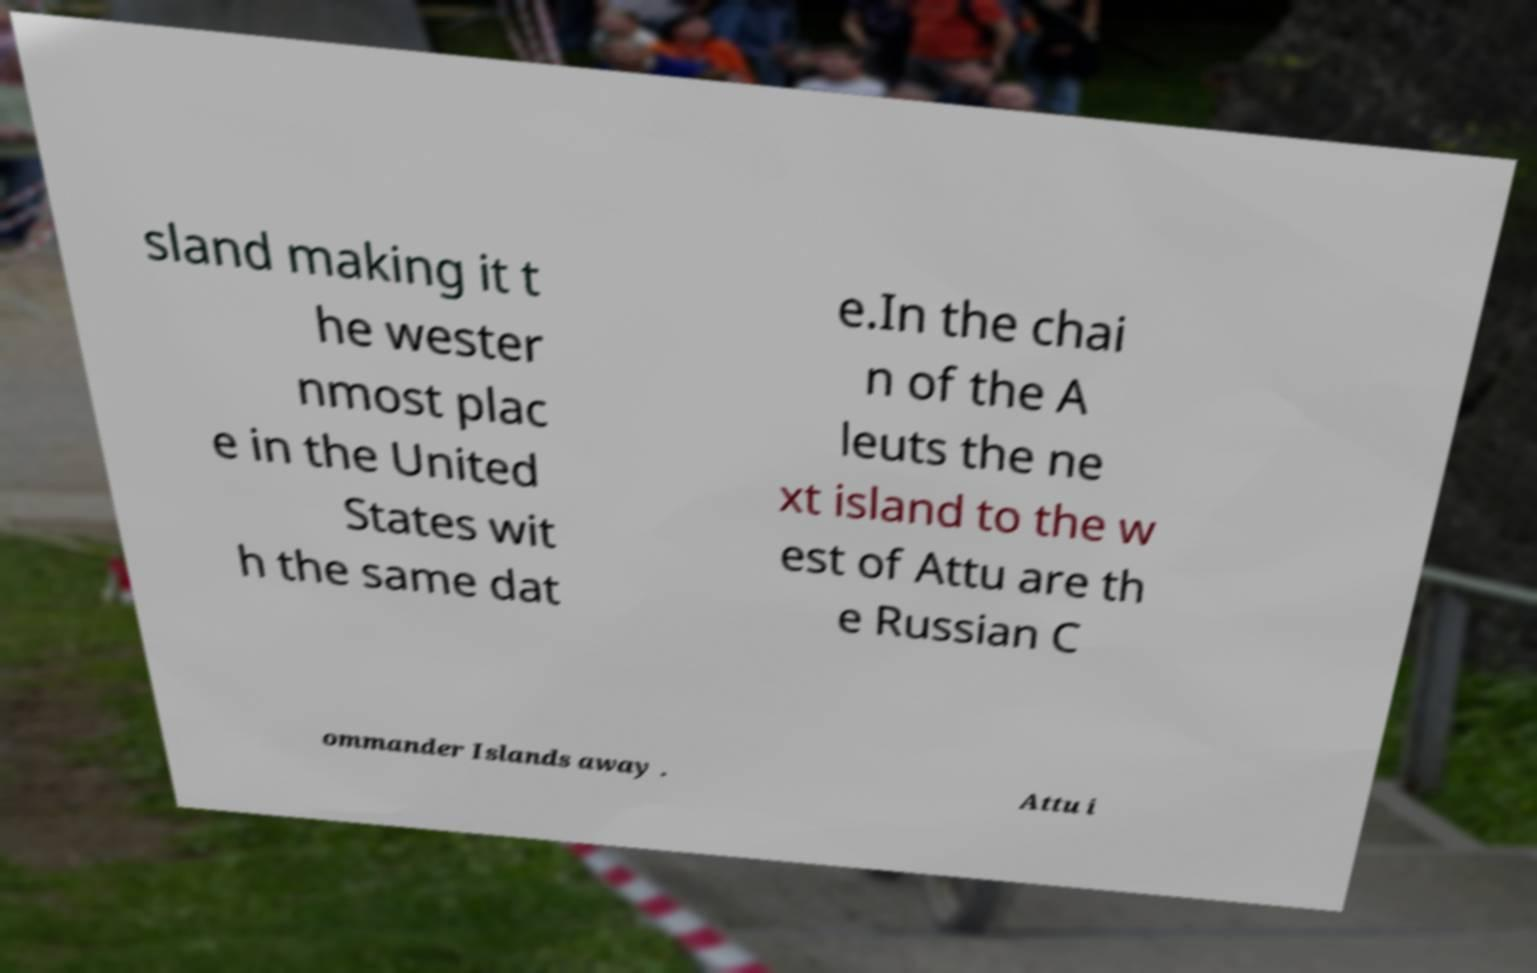For documentation purposes, I need the text within this image transcribed. Could you provide that? sland making it t he wester nmost plac e in the United States wit h the same dat e.In the chai n of the A leuts the ne xt island to the w est of Attu are th e Russian C ommander Islands away . Attu i 